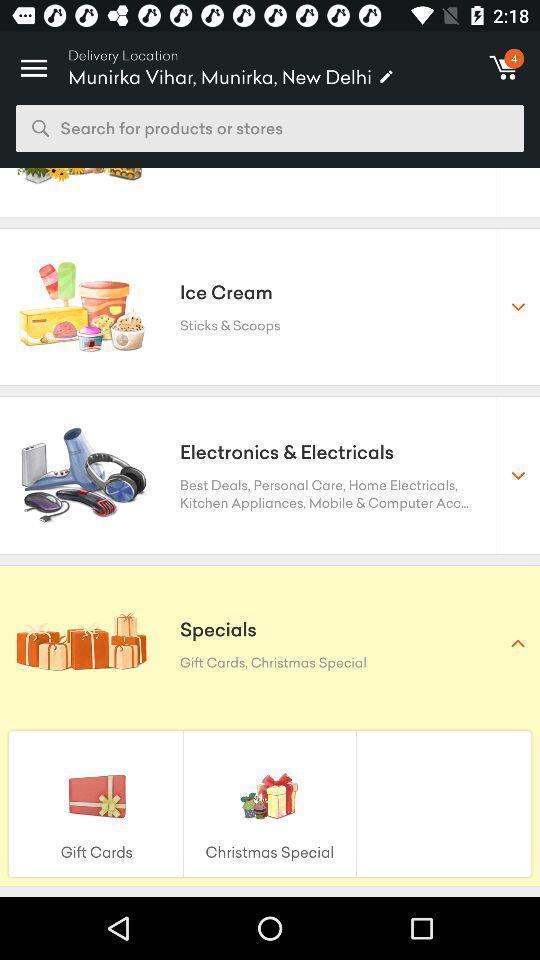Tell me about the visual elements in this screen capture. Screen shows items from an online store. 